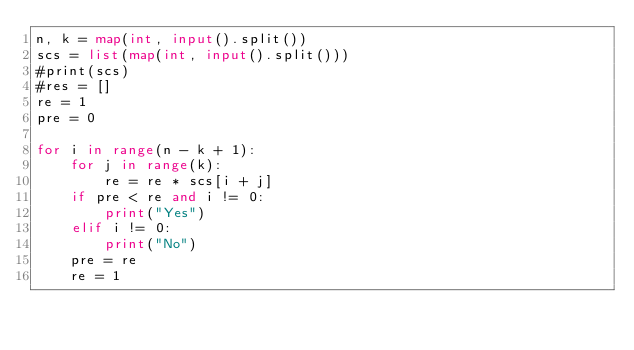Convert code to text. <code><loc_0><loc_0><loc_500><loc_500><_Python_>n, k = map(int, input().split())
scs = list(map(int, input().split()))
#print(scs)
#res = []
re = 1
pre = 0

for i in range(n - k + 1):
    for j in range(k):
        re = re * scs[i + j]
    if pre < re and i != 0:
        print("Yes")
    elif i != 0:
        print("No")
    pre = re
    re = 1</code> 